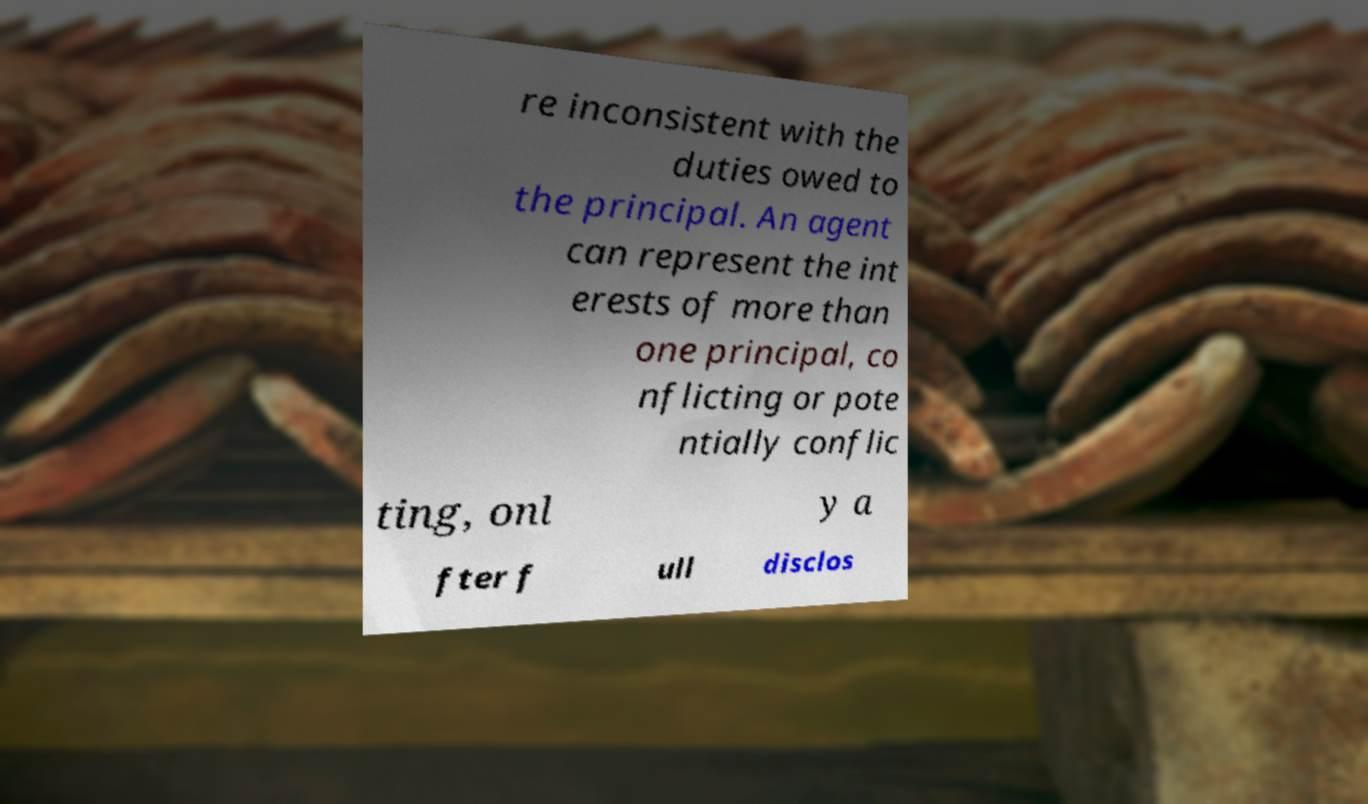Could you extract and type out the text from this image? re inconsistent with the duties owed to the principal. An agent can represent the int erests of more than one principal, co nflicting or pote ntially conflic ting, onl y a fter f ull disclos 